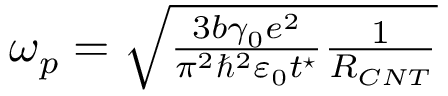Convert formula to latex. <formula><loc_0><loc_0><loc_500><loc_500>\begin{array} { r } { \omega _ { p } = \sqrt { \frac { 3 b \gamma _ { 0 } e ^ { 2 } } { \pi ^ { 2 } \hbar { ^ } { 2 } \varepsilon _ { 0 } t ^ { ^ { * } } } \frac { 1 } { R _ { C N T } } } } \end{array}</formula> 